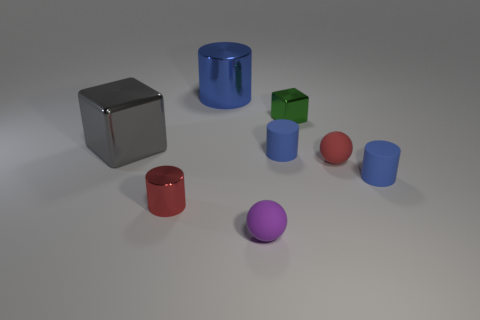What shape is the small object that is the same color as the tiny metallic cylinder?
Provide a succinct answer. Sphere. There is a big object to the right of the gray shiny block; is it the same color as the tiny thing right of the red matte thing?
Make the answer very short. Yes. The object that is the same color as the small metal cylinder is what size?
Your response must be concise. Small. What number of tiny objects are balls or shiny objects?
Offer a very short reply. 4. There is a big metallic object to the left of the tiny red shiny cylinder; what is its shape?
Offer a very short reply. Cube. Is there another tiny block that has the same color as the tiny block?
Your answer should be very brief. No. Does the cylinder that is behind the large gray block have the same size as the matte cylinder that is on the left side of the tiny green metal thing?
Ensure brevity in your answer.  No. Are there more blue objects in front of the gray cube than big metallic objects behind the tiny green block?
Your answer should be compact. Yes. Is there a tiny green object made of the same material as the big blue cylinder?
Give a very brief answer. Yes. There is a thing that is both in front of the tiny red ball and left of the big blue metal cylinder; what is its material?
Keep it short and to the point. Metal. 